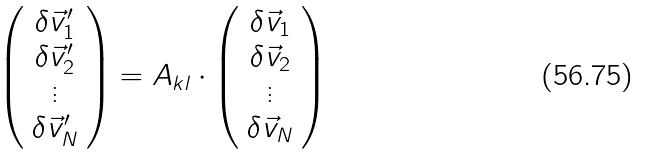Convert formula to latex. <formula><loc_0><loc_0><loc_500><loc_500>\left ( \begin{array} { c } \delta \vec { v } _ { 1 } ^ { \prime } \\ \delta \vec { v } _ { 2 } ^ { \prime } \\ \vdots \\ \delta \vec { v } _ { N } ^ { \prime } \end{array} \right ) = { A } _ { k l } \cdot \left ( \begin{array} { c } \delta \vec { v } _ { 1 } \\ \delta \vec { v } _ { 2 } \\ \vdots \\ \delta \vec { v } _ { N } \end{array} \right )</formula> 